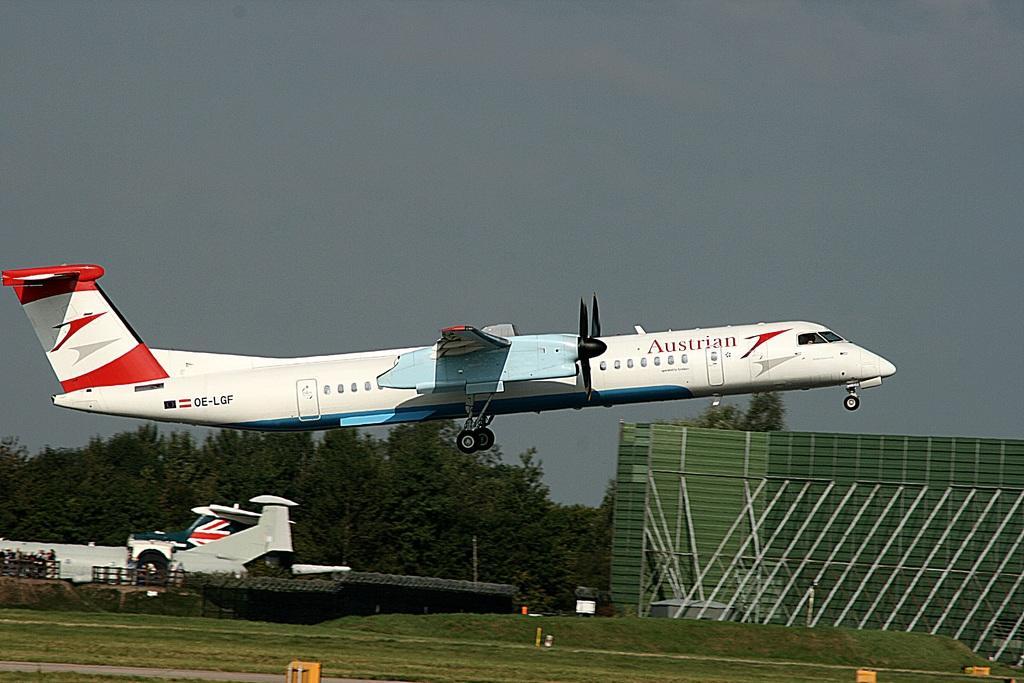In one or two sentences, can you explain what this image depicts? In this image we can see the grass, an airplane flying in the air, fence, trees, the wall and the cloudy sky in the background. 